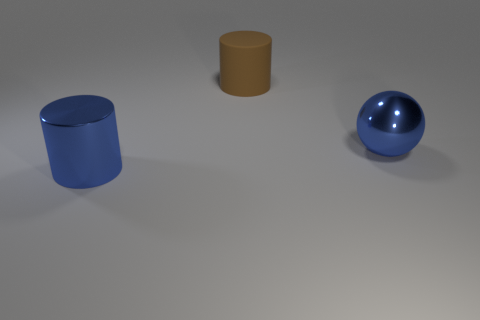Add 2 big spheres. How many objects exist? 5 Subtract all balls. How many objects are left? 2 Add 3 large blue cylinders. How many large blue cylinders exist? 4 Subtract 1 blue spheres. How many objects are left? 2 Subtract all small blue metal cylinders. Subtract all matte cylinders. How many objects are left? 2 Add 1 brown rubber cylinders. How many brown rubber cylinders are left? 2 